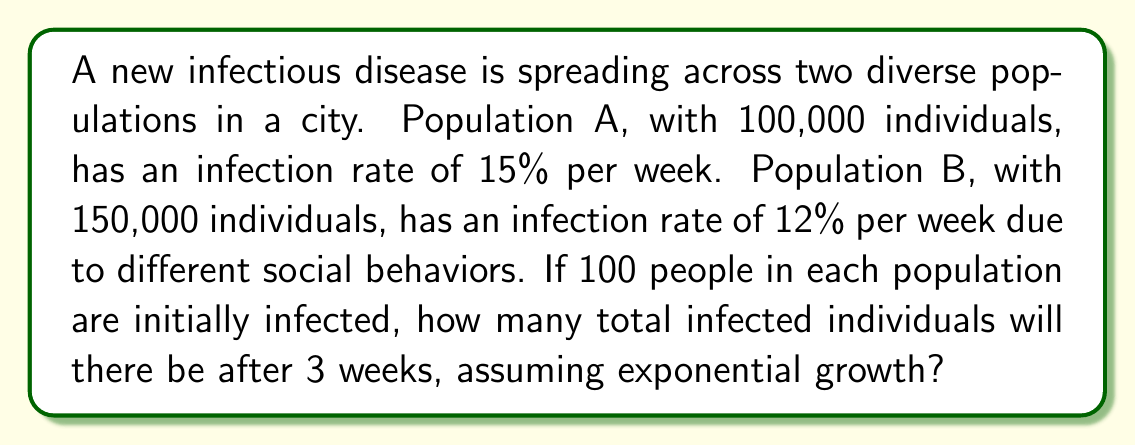Help me with this question. Let's solve this problem step-by-step:

1) For Population A:
   - Initial infected: 100
   - Growth rate: 15% = 0.15 per week
   - Time: 3 weeks

   Using the exponential growth formula: $A = P(1 + r)^t$
   Where A is the final amount, P is the initial amount, r is the growth rate, and t is time.

   $A_1 = 100(1 + 0.15)^3 = 100(1.15)^3 = 100 * 1.520875 = 152.0875$

2) For Population B:
   - Initial infected: 100
   - Growth rate: 12% = 0.12 per week
   - Time: 3 weeks

   $A_2 = 100(1 + 0.12)^3 = 100(1.12)^3 = 100 * 1.404928 = 140.4928$

3) Total infected after 3 weeks:
   $Total = A_1 + A_2 = 152.0875 + 140.4928 = 292.5803$

4) Since we're dealing with people, we round to the nearest whole number:
   $293$ infected individuals
Answer: 293 